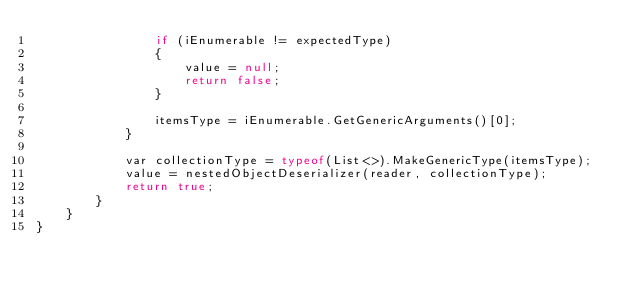<code> <loc_0><loc_0><loc_500><loc_500><_C#_>                if (iEnumerable != expectedType)
                {
                    value = null;
                    return false;
                }

                itemsType = iEnumerable.GetGenericArguments()[0];
            }

            var collectionType = typeof(List<>).MakeGenericType(itemsType);
            value = nestedObjectDeserializer(reader, collectionType);
            return true;
        }
    }
}

</code> 